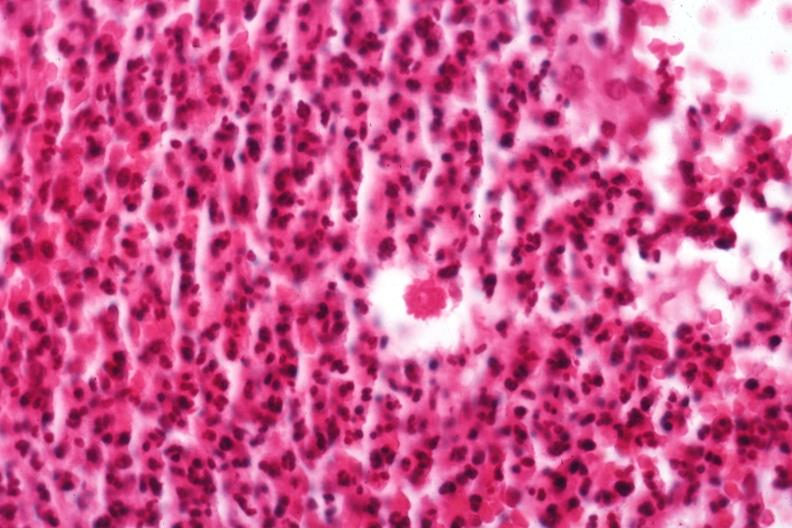s sporotrichosis present?
Answer the question using a single word or phrase. Yes 